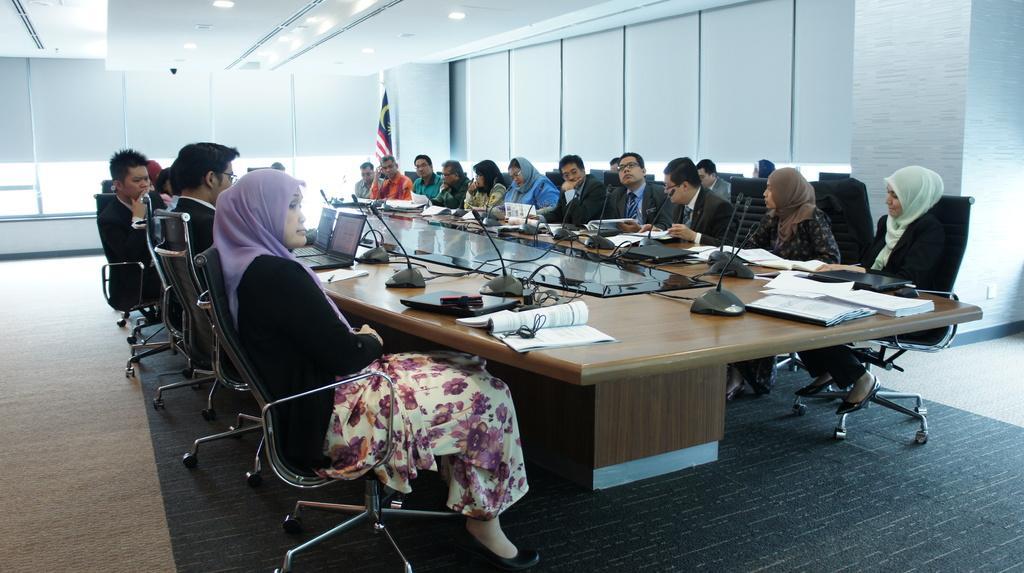In one or two sentences, can you explain what this image depicts? There is a room. They are sitting in a chair. There is a table. There is a laptop,book,mic board on a table. we can see in the background there is a flag ,window and lights. 